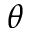<formula> <loc_0><loc_0><loc_500><loc_500>\theta</formula> 